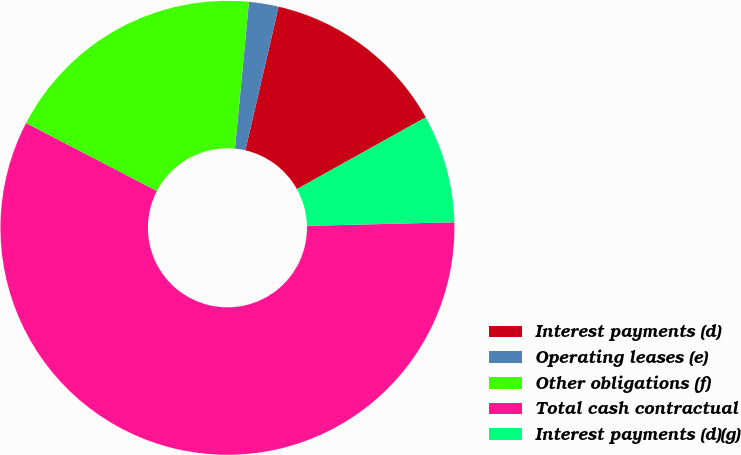<chart> <loc_0><loc_0><loc_500><loc_500><pie_chart><fcel>Interest payments (d)<fcel>Operating leases (e)<fcel>Other obligations (f)<fcel>Total cash contractual<fcel>Interest payments (d)(g)<nl><fcel>13.29%<fcel>2.11%<fcel>18.88%<fcel>58.02%<fcel>7.7%<nl></chart> 